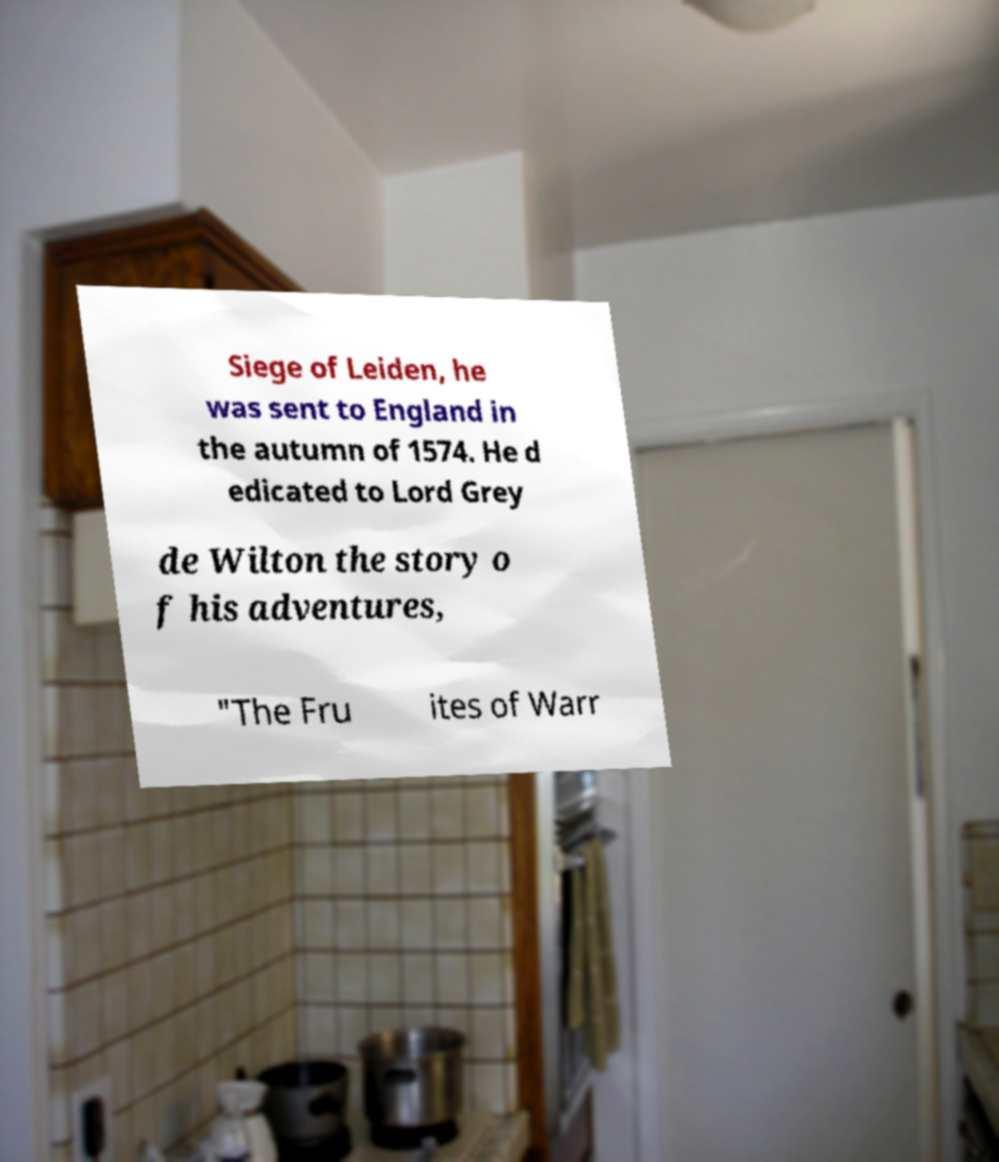For documentation purposes, I need the text within this image transcribed. Could you provide that? Siege of Leiden, he was sent to England in the autumn of 1574. He d edicated to Lord Grey de Wilton the story o f his adventures, "The Fru ites of Warr 